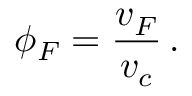<formula> <loc_0><loc_0><loc_500><loc_500>\phi _ { F } = \frac { v _ { F } } { v _ { c } } \, .</formula> 